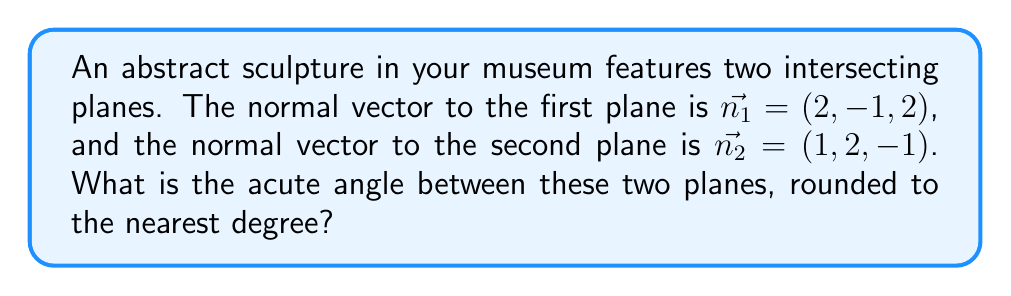Help me with this question. To find the angle between two intersecting planes, we can use the angle between their normal vectors. The process is as follows:

1) The angle $\theta$ between two vectors $\vec{a}$ and $\vec{b}$ is given by the formula:

   $$\cos \theta = \frac{\vec{a} \cdot \vec{b}}{|\vec{a}| |\vec{b}|}$$

2) We have $\vec{n_1} = (2, -1, 2)$ and $\vec{n_2} = (1, 2, -1)$. Let's calculate the dot product:

   $$\vec{n_1} \cdot \vec{n_2} = (2)(1) + (-1)(2) + (2)(-1) = 2 - 2 - 2 = -2$$

3) Now, let's calculate the magnitudes:

   $$|\vec{n_1}| = \sqrt{2^2 + (-1)^2 + 2^2} = \sqrt{4 + 1 + 4} = \sqrt{9} = 3$$
   $$|\vec{n_2}| = \sqrt{1^2 + 2^2 + (-1)^2} = \sqrt{1 + 4 + 1} = \sqrt{6}$$

4) Substituting into our formula:

   $$\cos \theta = \frac{-2}{3\sqrt{6}}$$

5) To find $\theta$, we take the inverse cosine (arccos) of both sides:

   $$\theta = \arccos(\frac{-2}{3\sqrt{6}}) \approx 1.9106 \text{ radians}$$

6) Converting to degrees:

   $$\theta \approx 1.9106 \times \frac{180}{\pi} \approx 109.47°$$

7) The question asks for the acute angle, which is the complement of this angle:

   $$180° - 109.47° = 70.53°$$

8) Rounding to the nearest degree:

   $$70.53° \approx 71°$$
Answer: 71° 